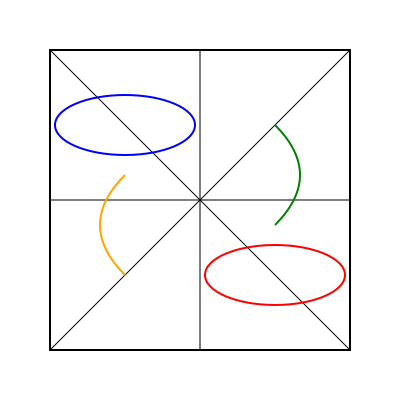You have a square storage container divided into four equal triangular sections. You need to arrange four different types of fish: cod (blue ellipse), salmon (red ellipse), herring (green curve), and Arctic char (orange curve). If you rotate the container 90° clockwise, which fish will occupy the top-right section? To solve this problem, we need to follow these steps:

1. Identify the current positions of the fish:
   - Cod (blue ellipse) is in the top-left section
   - Salmon (red ellipse) is in the bottom-right section
   - Herring (green curve) is in the top-right section
   - Arctic char (orange curve) is in the bottom-left section

2. Visualize a 90° clockwise rotation:
   - Top-left moves to top-right
   - Top-right moves to bottom-right
   - Bottom-right moves to bottom-left
   - Bottom-left moves to top-left

3. Track the movement of each fish:
   - Cod moves from top-left to top-right
   - Salmon moves from bottom-right to bottom-left
   - Herring moves from top-right to bottom-right
   - Arctic char moves from bottom-left to top-left

4. Identify which fish ends up in the top-right section:
   After the rotation, the cod (blue ellipse) will occupy the top-right section.
Answer: Cod 